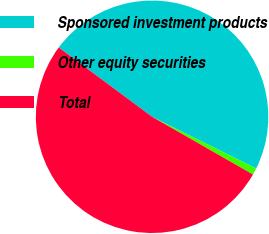Convert chart to OTSL. <chart><loc_0><loc_0><loc_500><loc_500><pie_chart><fcel>Sponsored investment products<fcel>Other equity securities<fcel>Total<nl><fcel>47.18%<fcel>0.93%<fcel>51.9%<nl></chart> 